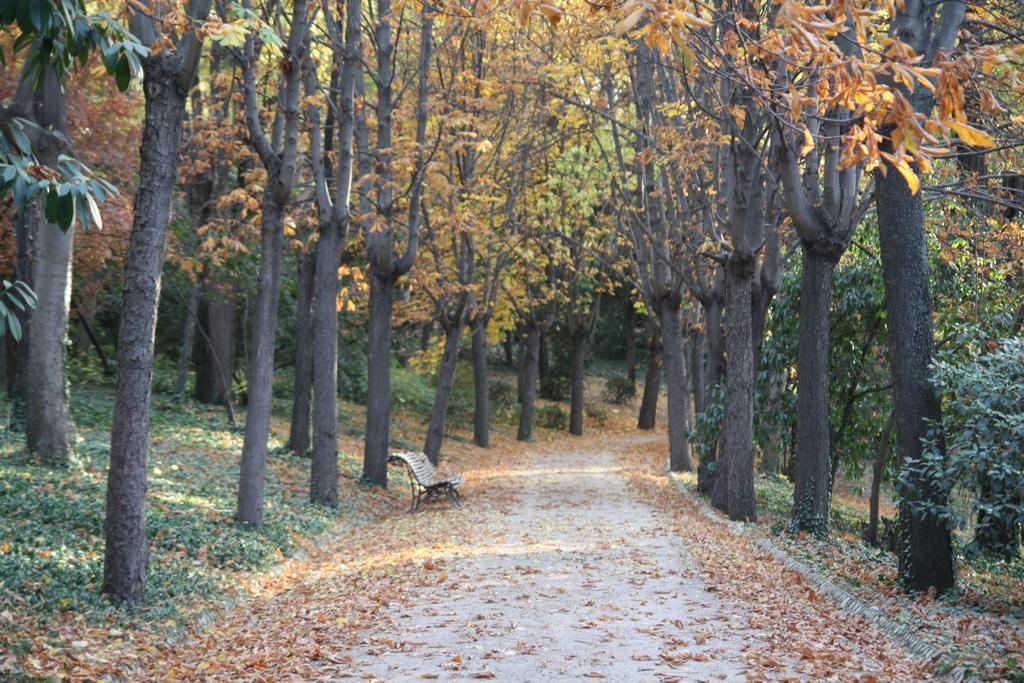What type of seating is visible in the image? There is a bench in the image. What color is the bench? The bench is cream-colored. What can be seen in the background of the image? There are trees in the background of the image. What colors are the trees? The trees have green and brown colors. How far away is the ship from the bench in the image? There is no ship present in the image, so it cannot be determined how far away it might be from the bench. 